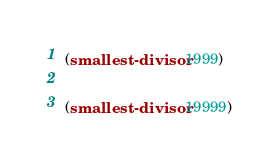Convert code to text. <code><loc_0><loc_0><loc_500><loc_500><_Scheme_>
(smallest-divisor 1999)

(smallest-divisor 19999)
</code> 